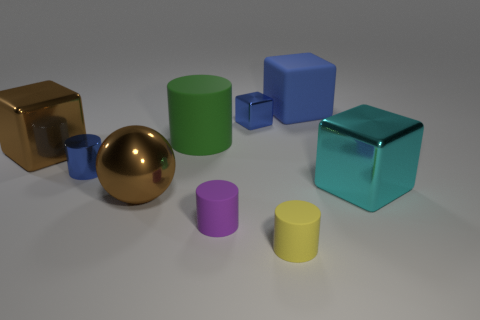How many other things are the same color as the small shiny cylinder?
Offer a very short reply. 2. Is there a large blue matte thing that has the same shape as the green rubber object?
Make the answer very short. No. Is the small purple object made of the same material as the blue block on the left side of the tiny yellow object?
Ensure brevity in your answer.  No. What color is the big metallic object on the left side of the large brown thing in front of the large metallic block to the right of the big blue rubber thing?
Make the answer very short. Brown. What material is the green cylinder that is the same size as the cyan shiny object?
Provide a succinct answer. Rubber. How many big cyan blocks are the same material as the tiny purple thing?
Offer a terse response. 0. There is a blue cube to the left of the big blue matte block; is its size the same as the cylinder left of the big cylinder?
Keep it short and to the point. Yes. What is the color of the large matte thing left of the blue matte block?
Offer a very short reply. Green. What material is the large cube that is the same color as the metallic cylinder?
Give a very brief answer. Rubber. What number of big things have the same color as the shiny cylinder?
Provide a short and direct response. 1. 